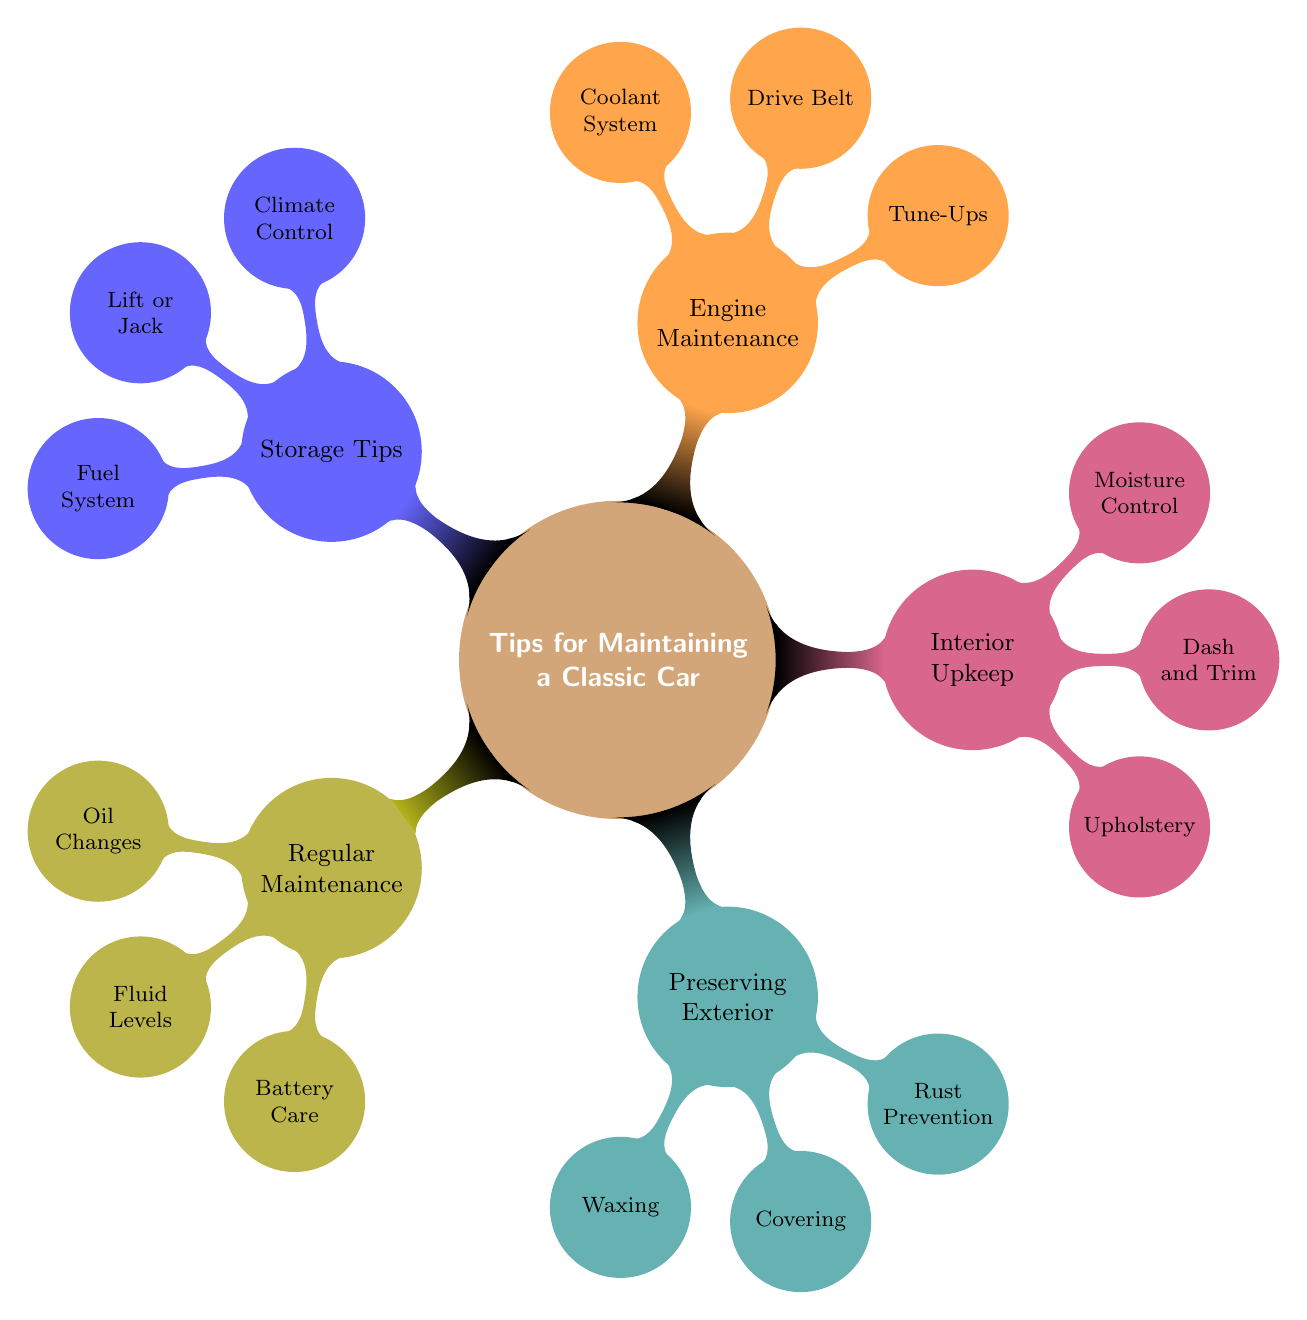What is the main topic of the diagram? The diagram's main topic is prominently placed at the center, which is: "Tips for Maintaining a Classic Car".
Answer: Tips for Maintaining a Classic Car How many main categories are there? There are five main categories represented as child nodes branching out from the central topic. Each category addresses a different aspect of maintaining a classic car.
Answer: 5 What is one subtopic under "Engine Maintenance"? One of the subtopics under "Engine Maintenance" can be directly identified in the diagram as "Tune-Ups".
Answer: Tune-Ups Which category includes "Moisture Control"? "Moisture Control" is listed under the "Interior Upkeep" category, indicating it is related to maintaining the interior of the classic car.
Answer: Interior Upkeep What action is suggested for battery care? Under the "Battery Care" node, it suggests performing "Monthly checks and clean terminals", showing how to maintain the battery effectively.
Answer: Monthly checks and clean terminals Name a preservation method for the exterior. The diagram specifies "Waxing" as a preservation method under the "Preserving Exterior" category, indicating how to protect the car's exterior finish.
Answer: Waxing What is recommended for fuel system care? The diagram indicates that it is advised to "Add fuel stabilizer to prevent fuel degradation" under the "Fuel System" node in the "Storage Tips" category.
Answer: Add fuel stabilizer to prevent fuel degradation Explain the relationship between "Drive Belt" and "Engine Maintenance". "Drive Belt" is a specific task that falls under the "Engine Maintenance" category, meaning it is part of the overall maintenance tasks needed to keep the engine in good working condition.
Answer: Part of engine maintenance How often should coolant be flushed according to the diagram? It is indicated in the "Coolant System" node that the coolant should be "Flushed and refill coolant system annually", providing a clear maintenance schedule for the coolant.
Answer: Annually 